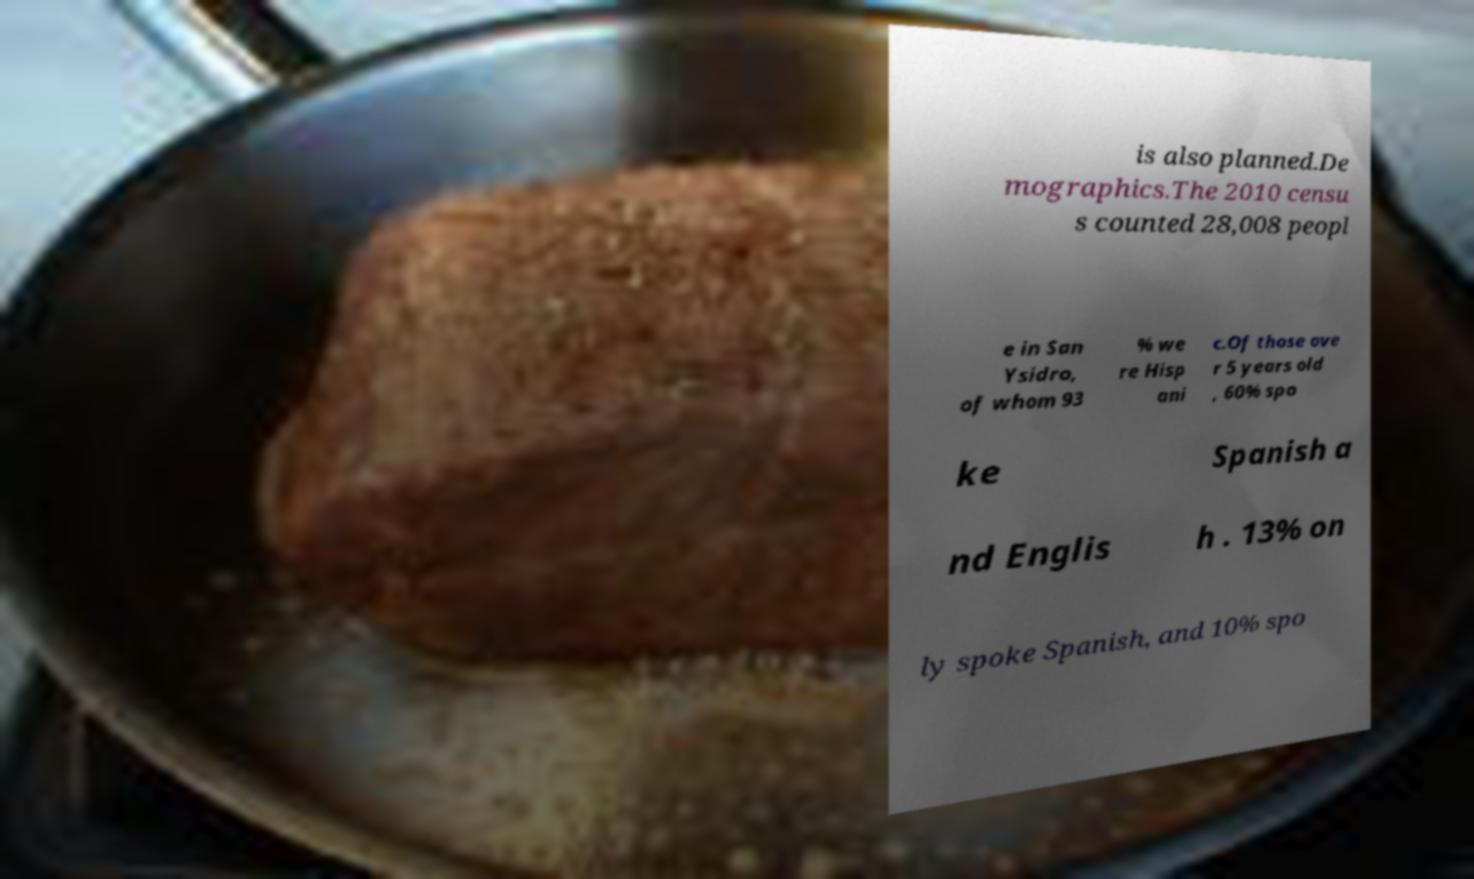There's text embedded in this image that I need extracted. Can you transcribe it verbatim? is also planned.De mographics.The 2010 censu s counted 28,008 peopl e in San Ysidro, of whom 93 % we re Hisp ani c.Of those ove r 5 years old , 60% spo ke Spanish a nd Englis h . 13% on ly spoke Spanish, and 10% spo 